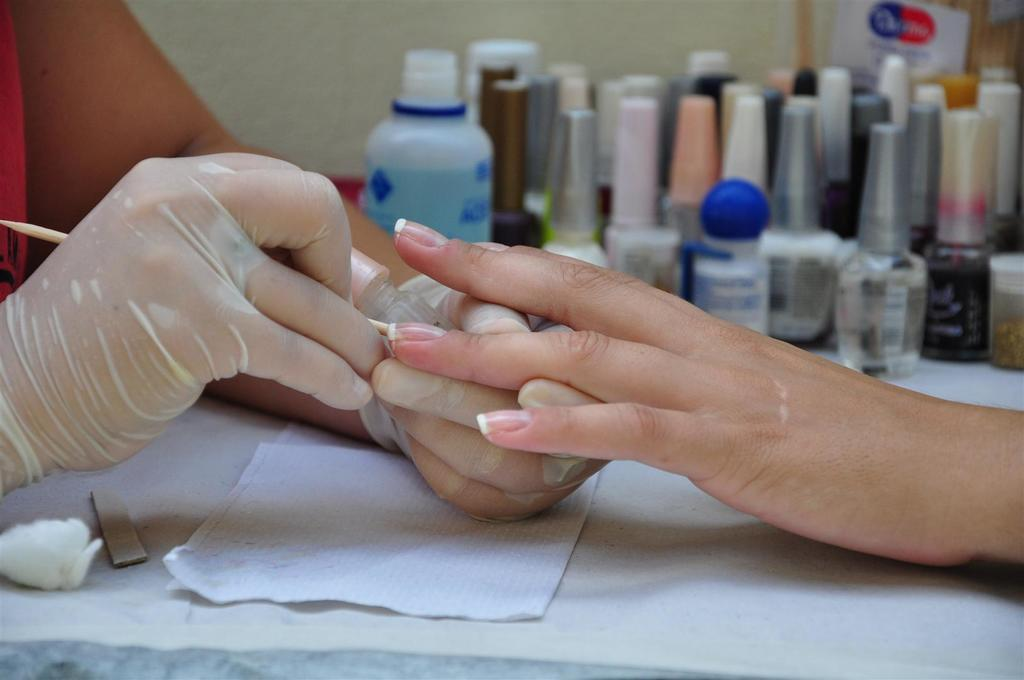How many people are in the image? There are two persons in the image. What are the two people doing in the image? One person is brushing the other person's nail. What can be seen besides the people in the image? There are liquids visible in the image, and nail polish is present. What is on the table in the image? Tissue paper is on the table in the image. What type of country is depicted in the image? There is no country depicted in the image; it features two people and various items related to nail care. Can you tell me how many cars are visible in the image? There are no cars present in the image. 